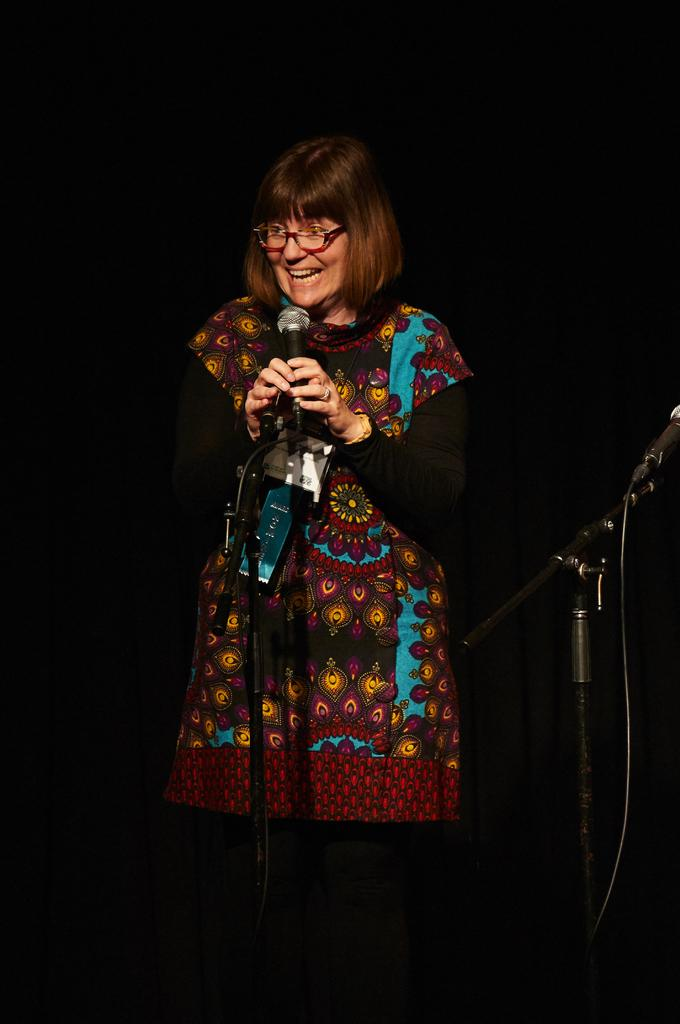Who or what is the main subject in the image? There is a person in the image. What is the person holding in the image? The person is holding a microphone. Can you describe the person's attire in the image? The person is wearing a brown and blue color dress. What can be observed about the background of the image? The background of the image is dark. What type of oil can be seen dripping from the person's dress in the image? There is no oil present in the image, and the person's dress is not depicted as dripping anything. 